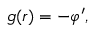<formula> <loc_0><loc_0><loc_500><loc_500>g ( r ) = - \varphi ^ { \prime } ,</formula> 